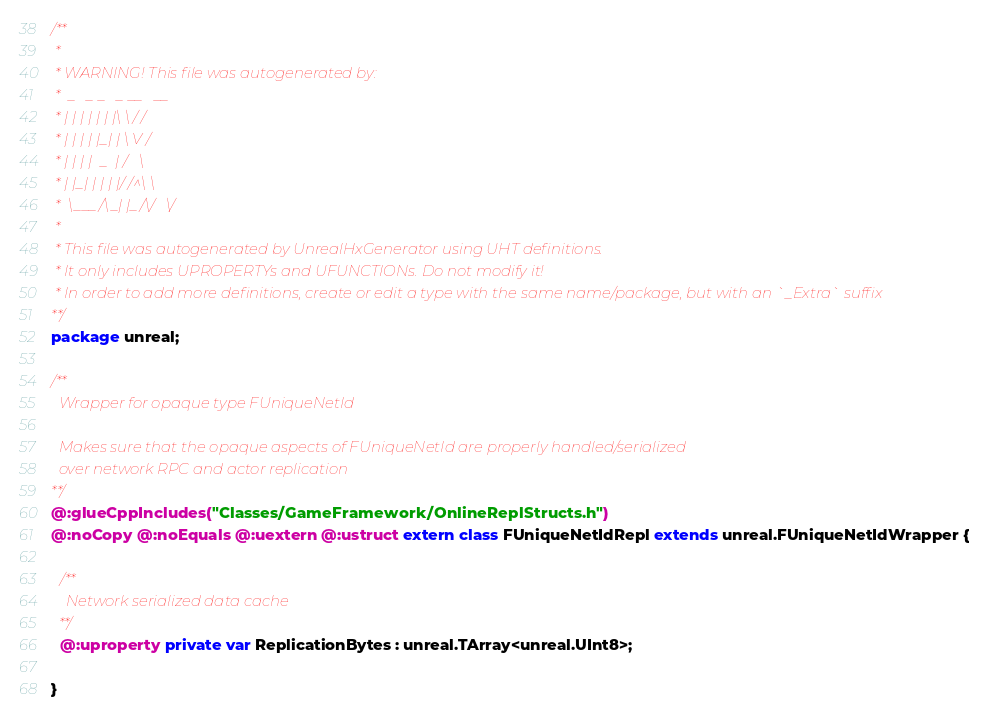<code> <loc_0><loc_0><loc_500><loc_500><_Haxe_>/**
 * 
 * WARNING! This file was autogenerated by: 
 *  _   _ _   _ __   __ 
 * | | | | | | |\ \ / / 
 * | | | | |_| | \ V /  
 * | | | |  _  | /   \  
 * | |_| | | | |/ /^\ \ 
 *  \___/\_| |_/\/   \/ 
 * 
 * This file was autogenerated by UnrealHxGenerator using UHT definitions.
 * It only includes UPROPERTYs and UFUNCTIONs. Do not modify it!
 * In order to add more definitions, create or edit a type with the same name/package, but with an `_Extra` suffix
**/
package unreal;

/**
  Wrapper for opaque type FUniqueNetId
  
  Makes sure that the opaque aspects of FUniqueNetId are properly handled/serialized
  over network RPC and actor replication
**/
@:glueCppIncludes("Classes/GameFramework/OnlineReplStructs.h")
@:noCopy @:noEquals @:uextern @:ustruct extern class FUniqueNetIdRepl extends unreal.FUniqueNetIdWrapper {
  
  /**
    Network serialized data cache
  **/
  @:uproperty private var ReplicationBytes : unreal.TArray<unreal.UInt8>;
  
}
</code> 